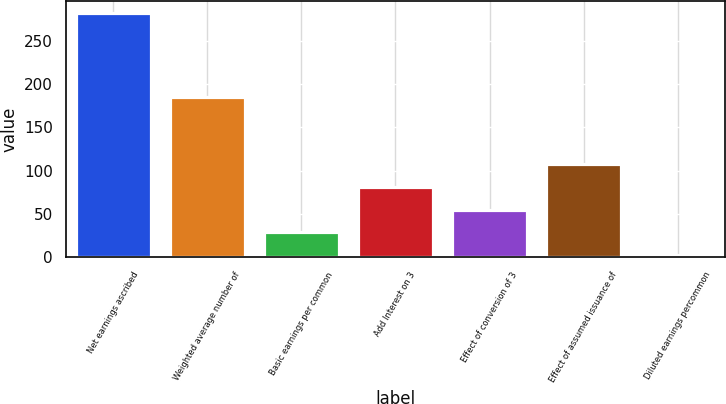Convert chart. <chart><loc_0><loc_0><loc_500><loc_500><bar_chart><fcel>Net earnings ascribed<fcel>Weighted average number of<fcel>Basic earnings per common<fcel>Add Interest on 3<fcel>Effect of conversion of 3<fcel>Effect of assumed issuance of<fcel>Diluted earnings percommon<nl><fcel>281.89<fcel>185.32<fcel>28.78<fcel>80.96<fcel>54.87<fcel>107.05<fcel>2.69<nl></chart> 